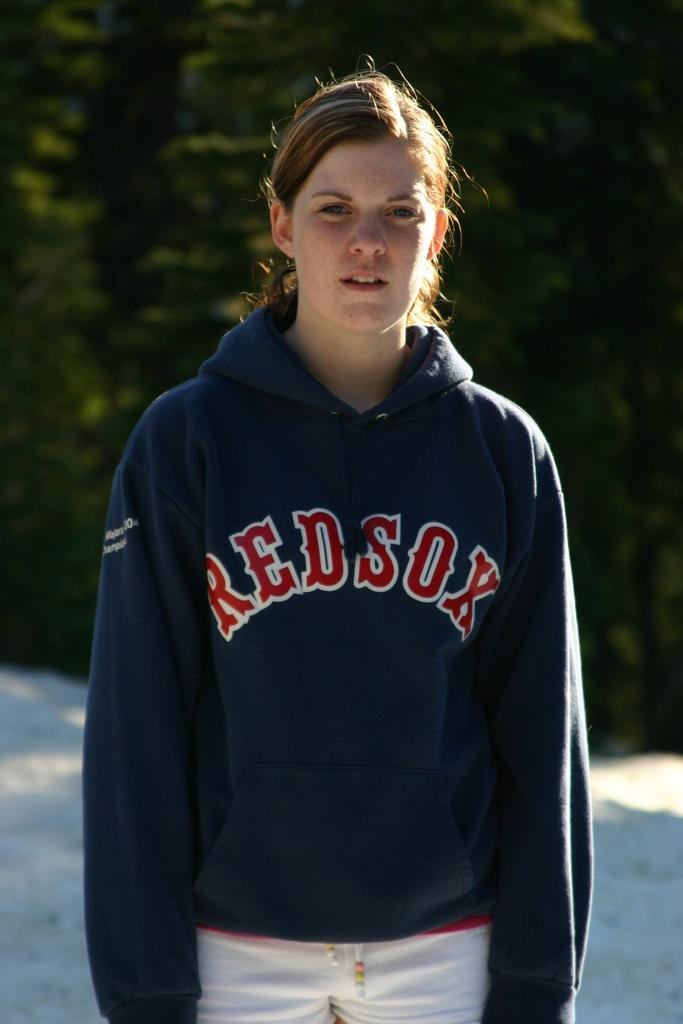<image>
Share a concise interpretation of the image provided. The person in the picture is wearing a Red Sox sweatshirt 